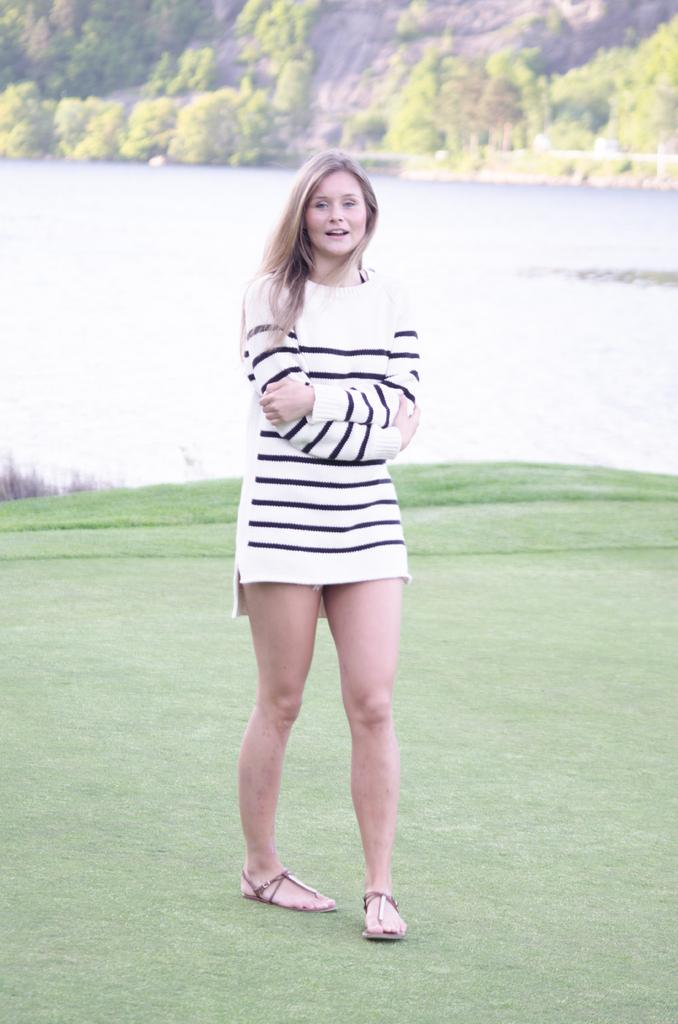Who is present in the image? There is a woman in the image. What type of vegetation can be seen in the image? There is grass in the image. What is the structure visible in the image? There is a wall in the image. What can be seen in the background of the image? A: There are trees in the background of the image. How many bags of popcorn are visible in the image? There are no bags of popcorn present in the image. What level of the building is the woman standing on in the image? The provided facts do not mention any information about the level or floor of the building, so it cannot be determined from the image. 